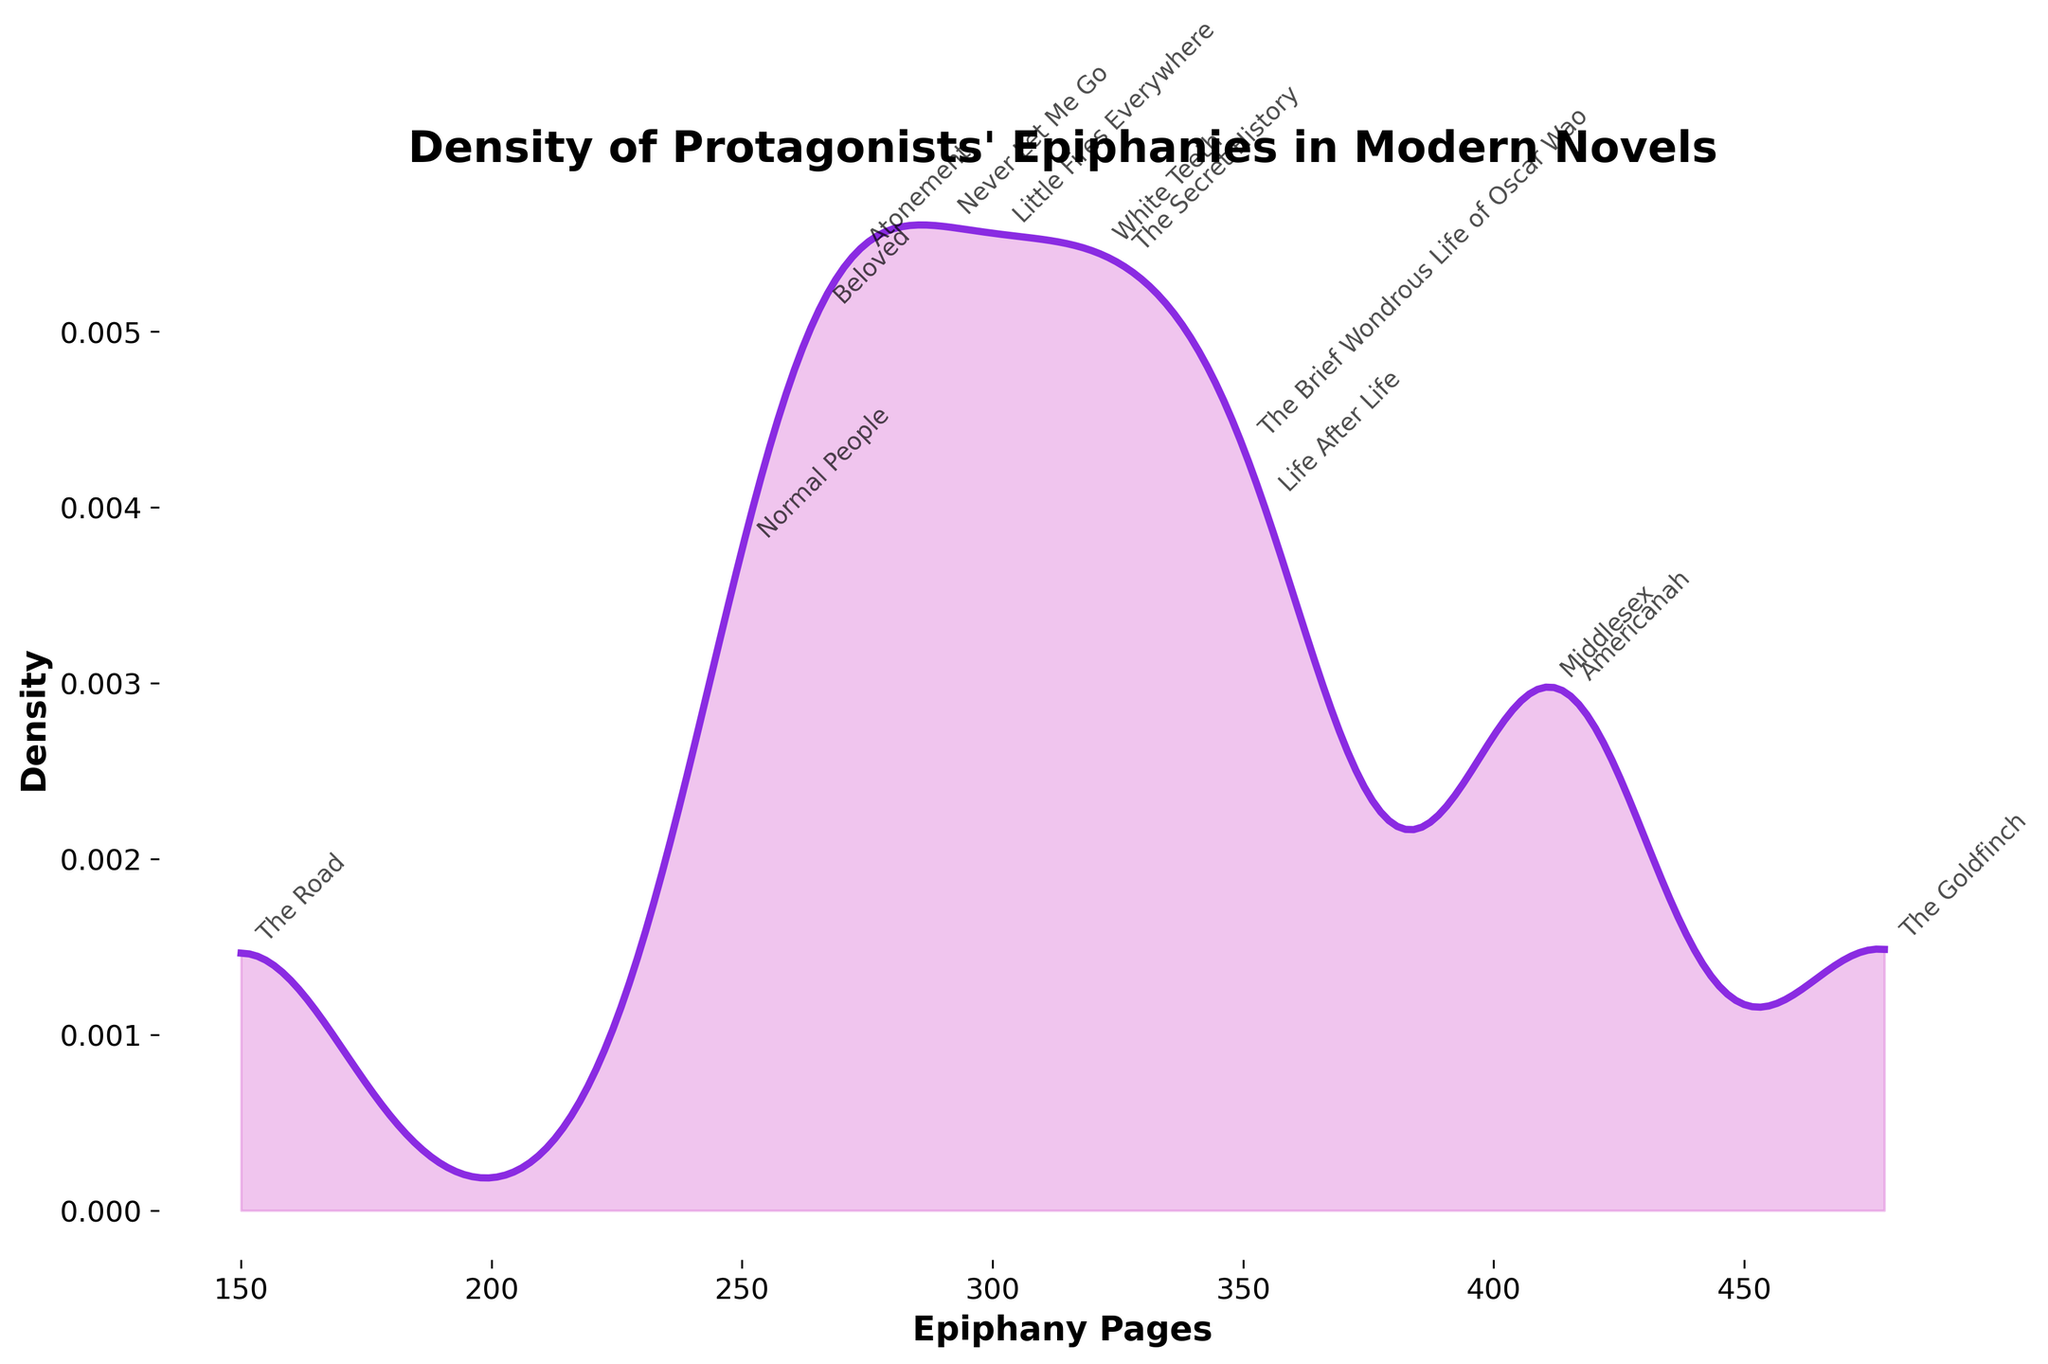What is the title of the figure? The title of the figure is displayed prominently at the top. It reads "Density of Protagonists' Epiphanies in Modern Novels."
Answer: Density of Protagonists' Epiphanies in Modern Novels Which novel has the highest density value for its epiphany page? Look for the peak in the density plot and locate the annotated novel closest to this peak.
Answer: "The Brief Wondrous Life of Oscar Wao" What is the minimum value on the x-axis? The x-axis represents the range of epiphany pages. The minimum value can be determined by looking at the leftmost point on the axis.
Answer: 150 What is the color used for the density line? The color of the density line can be determined by visually inspecting the plot. The line is colored in a distinct hue.
Answer: Purple How many novels are represented in the plot? Count the number of annotations or labeled points on the plot. Each annotation corresponds to a novel.
Answer: 13 What is the median epiphany page value for the novels? To find the median, list all the epiphany page values in ascending order and identify the middle value.
Answer: 301 Which novel has its epiphany on page 301? Locate the page number 301 on the plot and check the annotation corresponding to that point.
Answer: "Little Fires Everywhere" Between which two novels is the spread of epiphany pages the widest? Identify the novels with the minimum and maximum epiphany page numbers by observing the x-axis range and corresponding annotations.
Answer: "The Road" and "The Goldfinch" Which novels have their epiphanies at similar page numbers? Find clusters of annotations that are close to each other along the x-axis. For instance, compare page numbers that are close in value.
Answer: "White Teeth" and "The Secret History" Which novel has an epiphany page closest to the average page value? Calculate the average epiphany page value by summing all the page values and dividing by the number of novels. Identify the novel with a page value closest to this average.
Answer: "Little Fires Everywhere" 